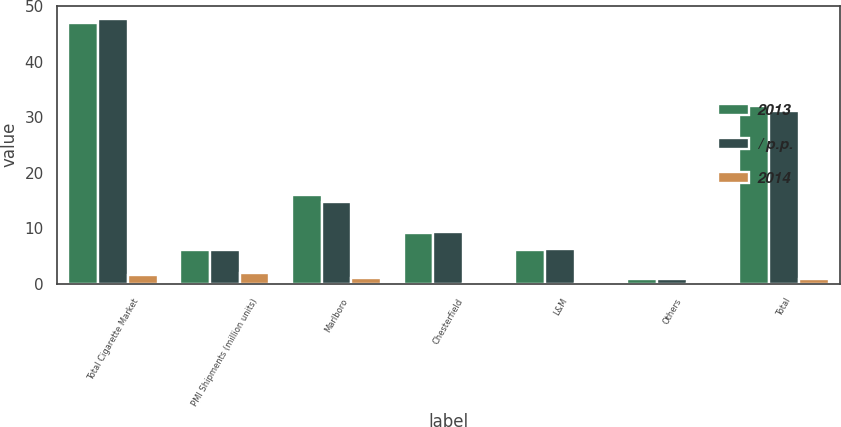Convert chart. <chart><loc_0><loc_0><loc_500><loc_500><stacked_bar_chart><ecel><fcel>Total Cigarette Market<fcel>PMI Shipments (million units)<fcel>Marlboro<fcel>Chesterfield<fcel>L&M<fcel>Others<fcel>Total<nl><fcel>2013<fcel>47<fcel>6.1<fcel>15.9<fcel>9.2<fcel>6.1<fcel>0.9<fcel>32.1<nl><fcel>/ p.p.<fcel>47.7<fcel>6.1<fcel>14.8<fcel>9.3<fcel>6.3<fcel>0.8<fcel>31.2<nl><fcel>2014<fcel>1.5<fcel>1.9<fcel>1.1<fcel>0.1<fcel>0.2<fcel>0.1<fcel>0.9<nl></chart> 